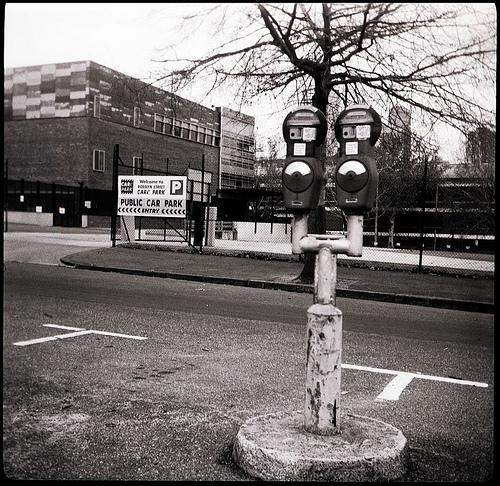How many parking meters are there?
Answer briefly. 2. Is this meter expired?
Keep it brief. Yes. Was the picture taken on a street corner?
Short answer required. No. What type of parking is available across the street?
Concise answer only. Public. What are on top of the red brick building?
Give a very brief answer. Windows. Is this a busy street?
Write a very short answer. No. 